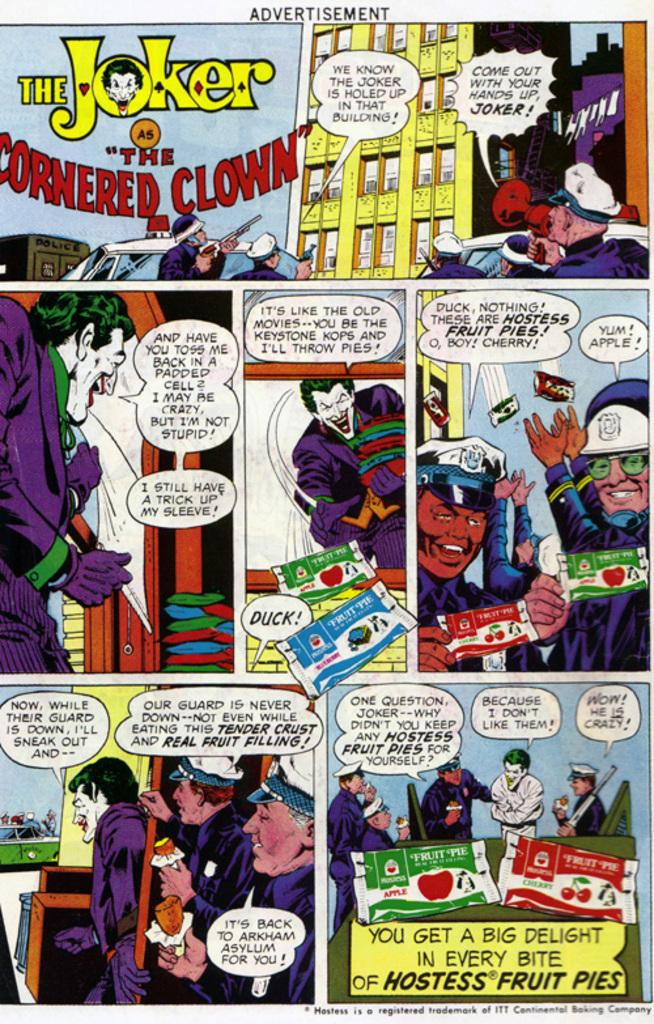<image>
Share a concise interpretation of the image provided. An advertisement for Hostess Fruit Pies featuring The Joker. 